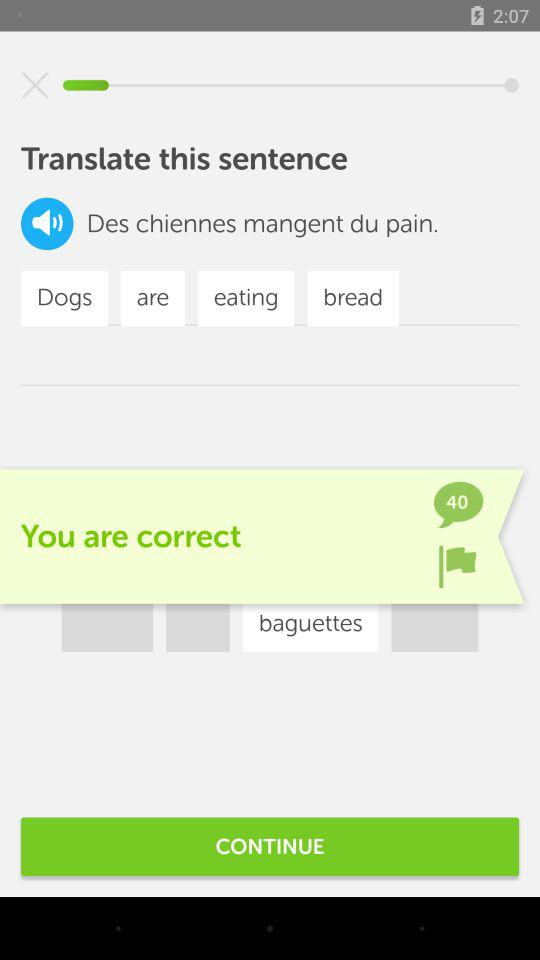How many comments are there on the "You are correct" pop-up? There are 40 comments. 